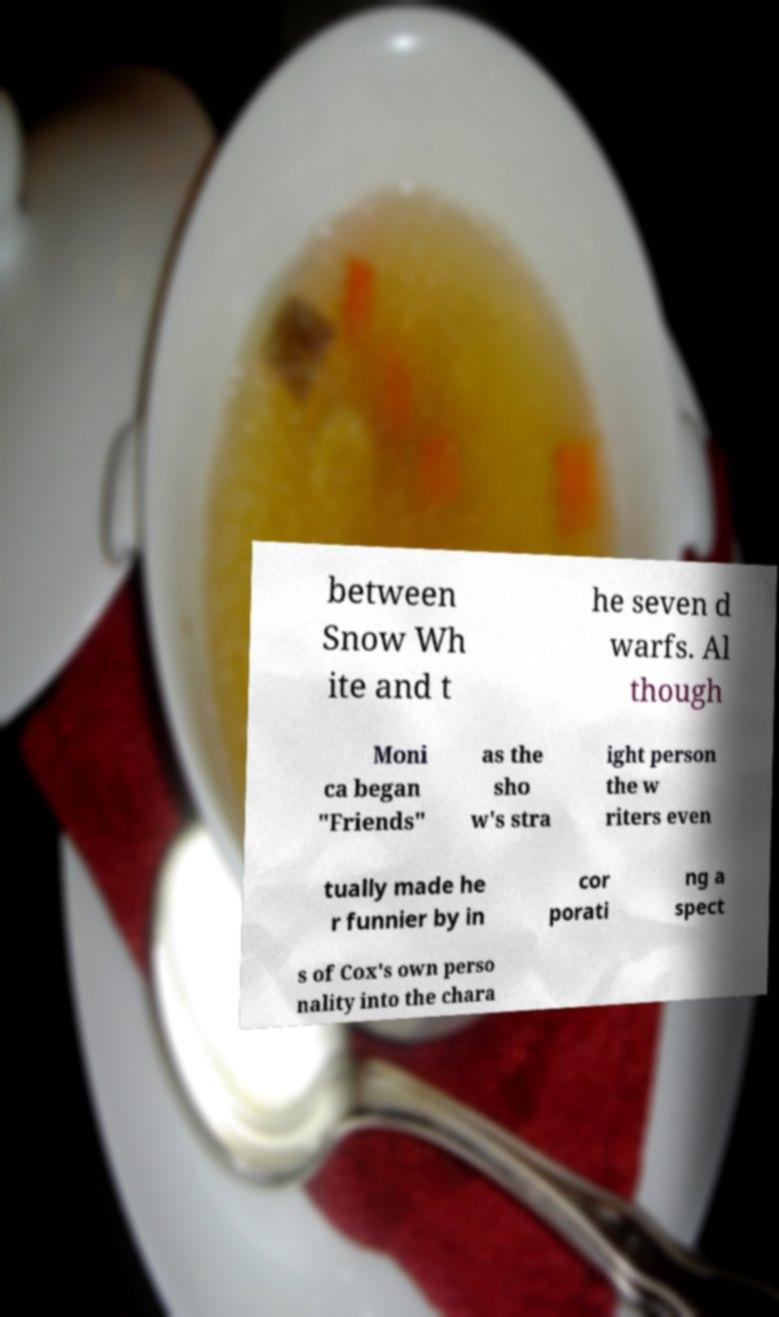Could you extract and type out the text from this image? between Snow Wh ite and t he seven d warfs. Al though Moni ca began "Friends" as the sho w's stra ight person the w riters even tually made he r funnier by in cor porati ng a spect s of Cox's own perso nality into the chara 